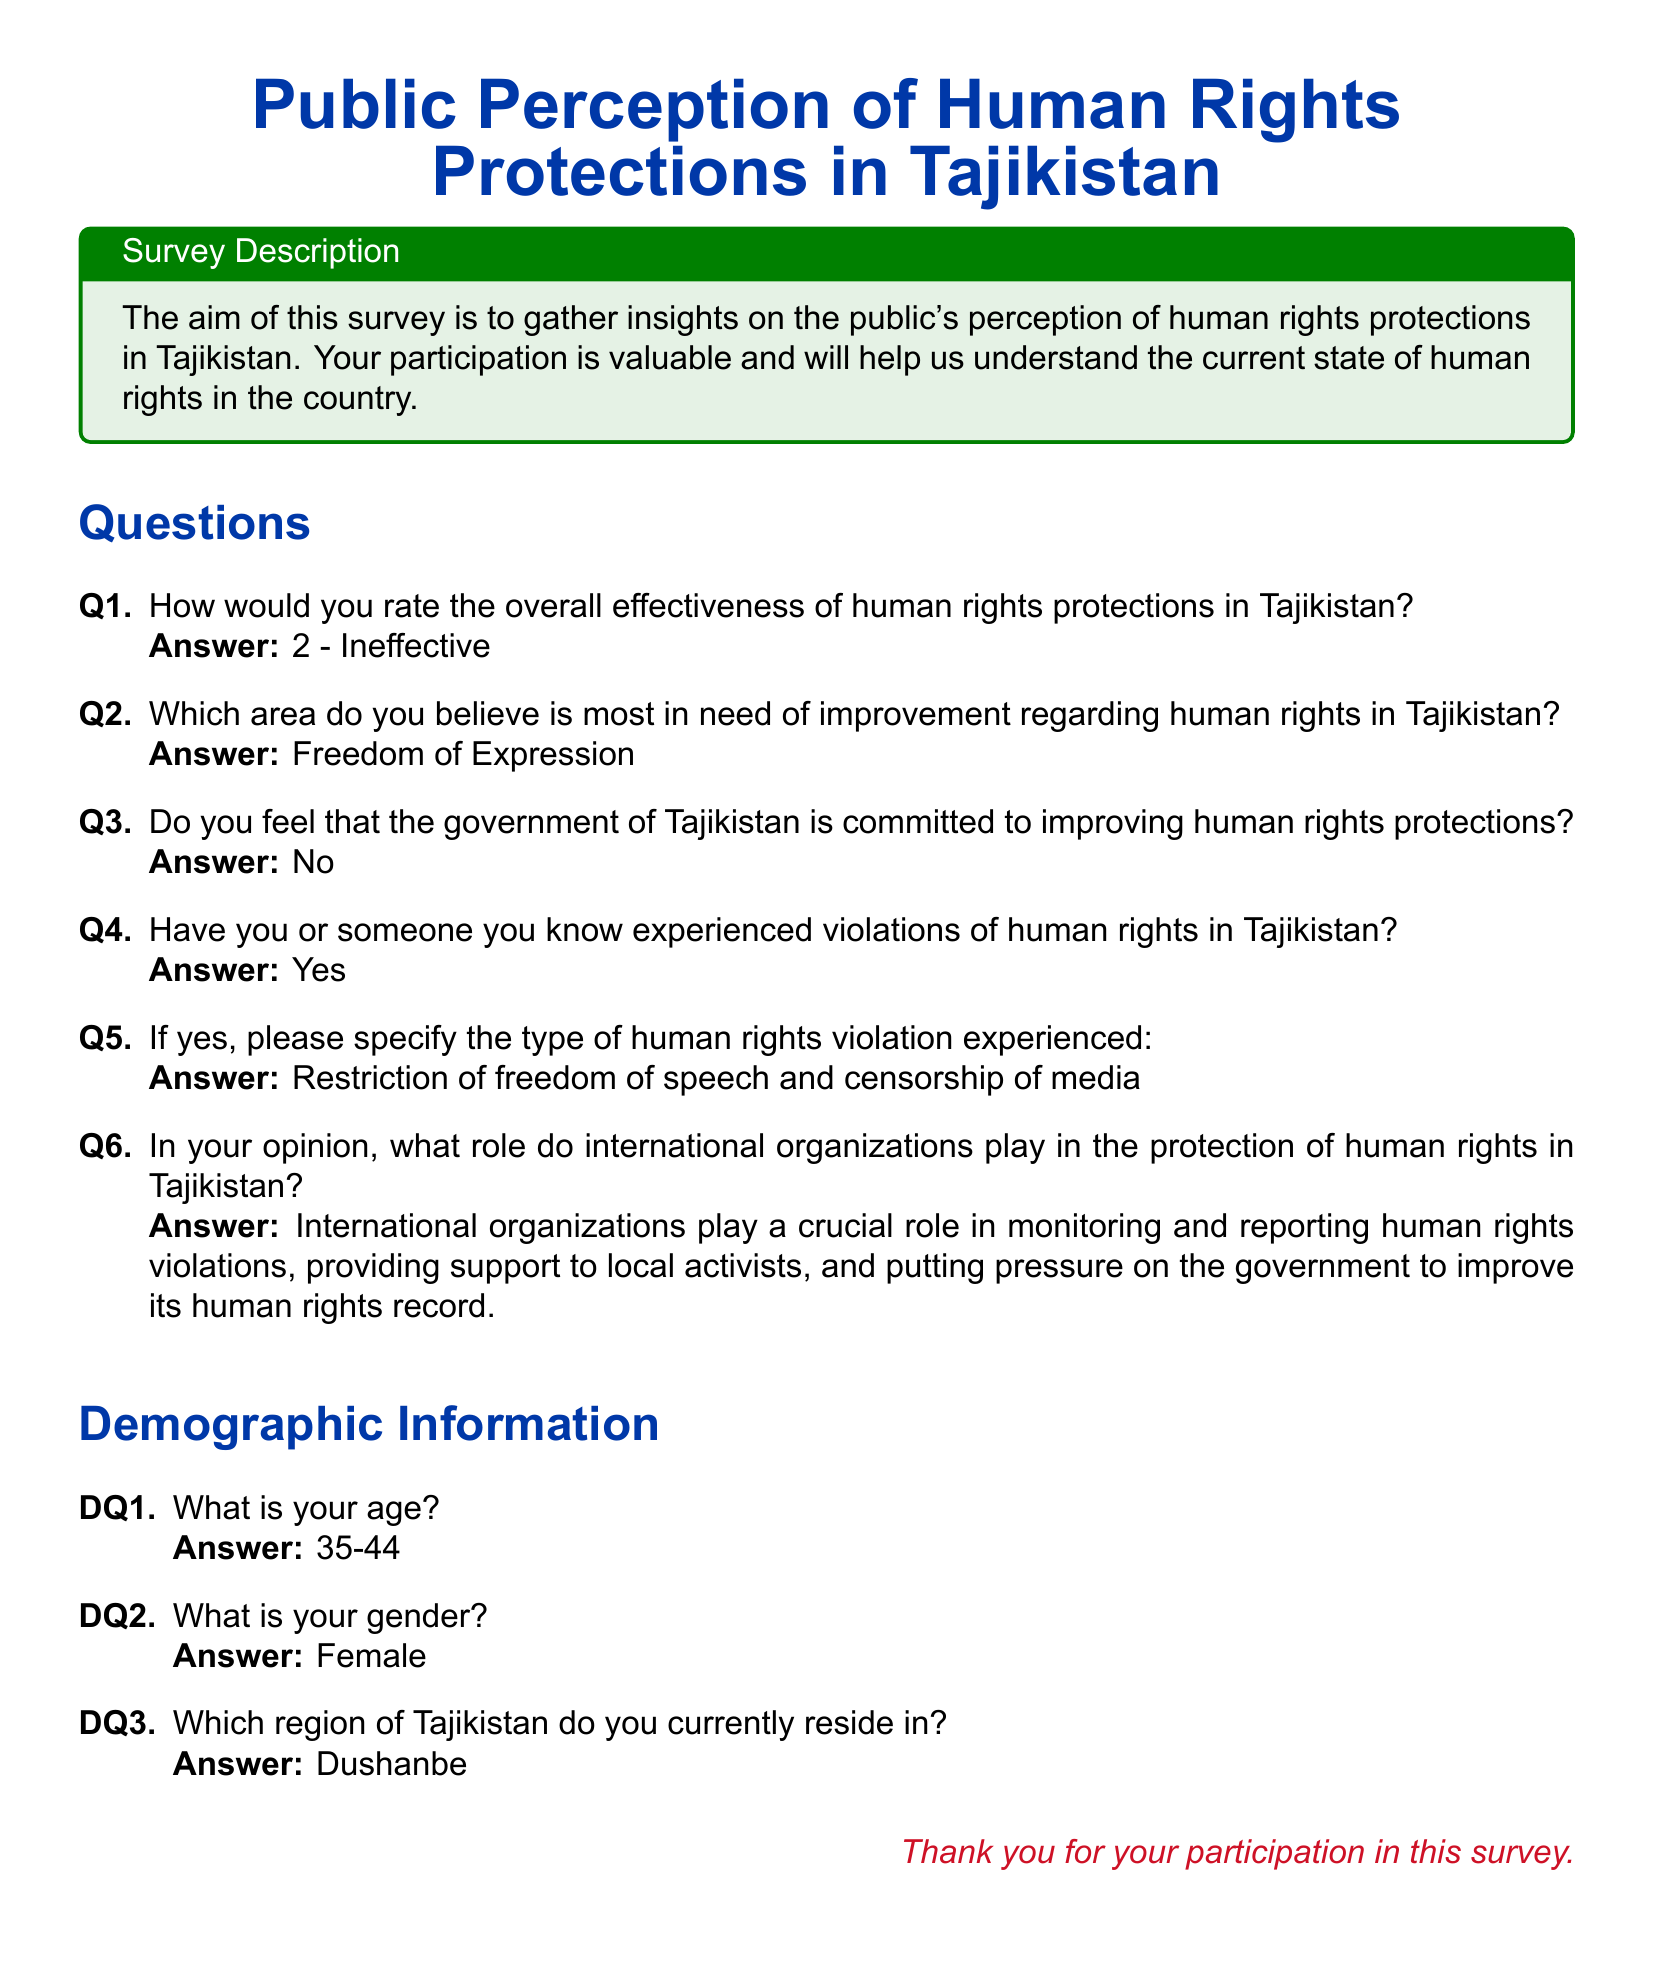How would you rate the overall effectiveness of human rights protections in Tajikistan? The answer indicates a rating system where 2 corresponds to "Ineffective."
Answer: 2 - Ineffective Which area is most in need of improvement regarding human rights in Tajikistan? The answer specifies a concern for freedom of expression based on the survey response.
Answer: Freedom of Expression Does the government of Tajikistan show commitment to improving human rights protections? The document states that the response to this question was "No."
Answer: No Have there been experiences of human rights violations? The answer reflects a positive experience of violations, indicating someone has faced issues.
Answer: Yes What type of human rights violation was experienced? The document elaborates that the type of violation mentioned is restrictions on freedom of speech and media censorship.
Answer: Restriction of freedom of speech and censorship of media What role do international organizations play in protecting human rights in Tajikistan? The answer highlights the importance of international organizations in monitoring and supporting local activists.
Answer: Crucial role in monitoring and reporting What is the age demographic of the respondent? According to the survey, the respondent falls within the age range of 35-44.
Answer: 35-44 What is the gender of the respondent? The document indicates that the respondent identifies as female.
Answer: Female In which region of Tajikistan does the respondent reside? The answer specifies the respondent's location as Dushanbe.
Answer: Dushanbe 